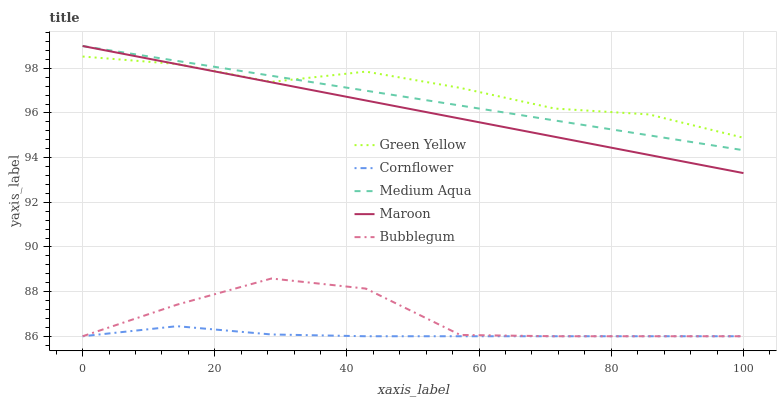Does Cornflower have the minimum area under the curve?
Answer yes or no. Yes. Does Green Yellow have the maximum area under the curve?
Answer yes or no. Yes. Does Medium Aqua have the minimum area under the curve?
Answer yes or no. No. Does Medium Aqua have the maximum area under the curve?
Answer yes or no. No. Is Medium Aqua the smoothest?
Answer yes or no. Yes. Is Bubblegum the roughest?
Answer yes or no. Yes. Is Green Yellow the smoothest?
Answer yes or no. No. Is Green Yellow the roughest?
Answer yes or no. No. Does Medium Aqua have the lowest value?
Answer yes or no. No. Does Maroon have the highest value?
Answer yes or no. Yes. Does Green Yellow have the highest value?
Answer yes or no. No. Is Cornflower less than Maroon?
Answer yes or no. Yes. Is Medium Aqua greater than Cornflower?
Answer yes or no. Yes. Does Medium Aqua intersect Maroon?
Answer yes or no. Yes. Is Medium Aqua less than Maroon?
Answer yes or no. No. Is Medium Aqua greater than Maroon?
Answer yes or no. No. Does Cornflower intersect Maroon?
Answer yes or no. No. 